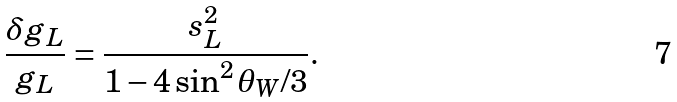Convert formula to latex. <formula><loc_0><loc_0><loc_500><loc_500>\frac { \delta g _ { L } } { g _ { L } } = \frac { s _ { L } ^ { 2 } } { 1 - 4 \sin ^ { 2 } \theta _ { W } / 3 } .</formula> 